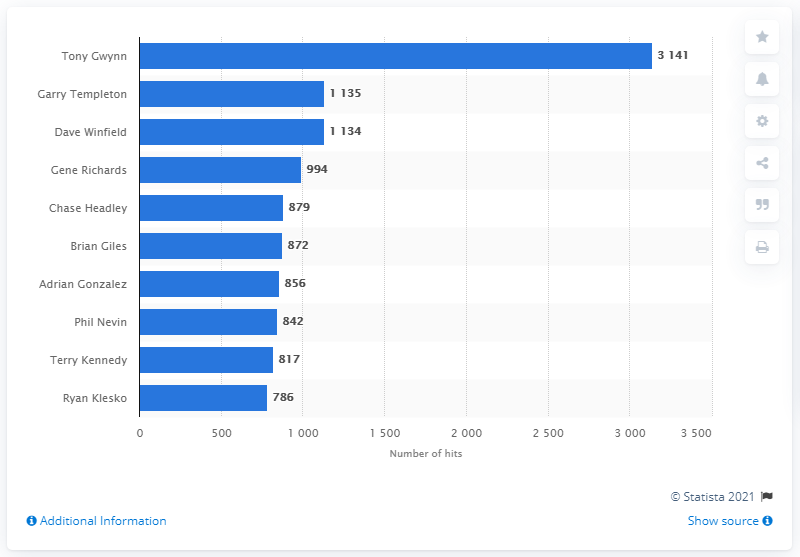Indicate a few pertinent items in this graphic. Tony Gwynn holds the record for the most hits in the history of the San Diego Padres franchise. 